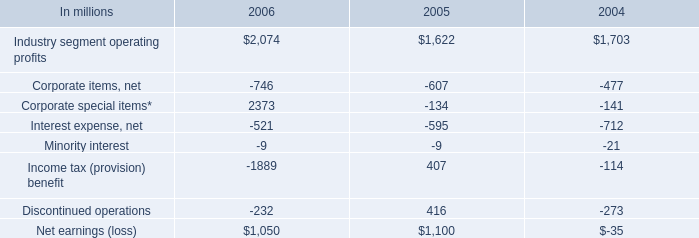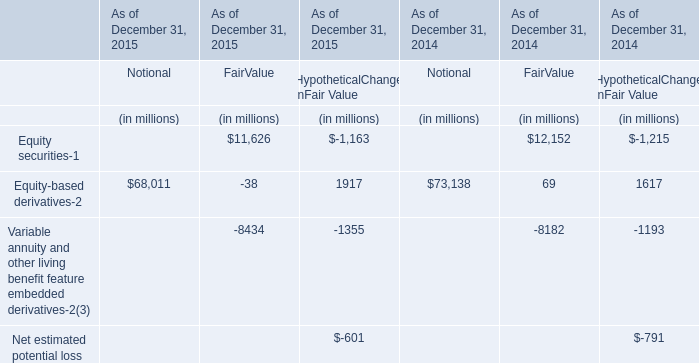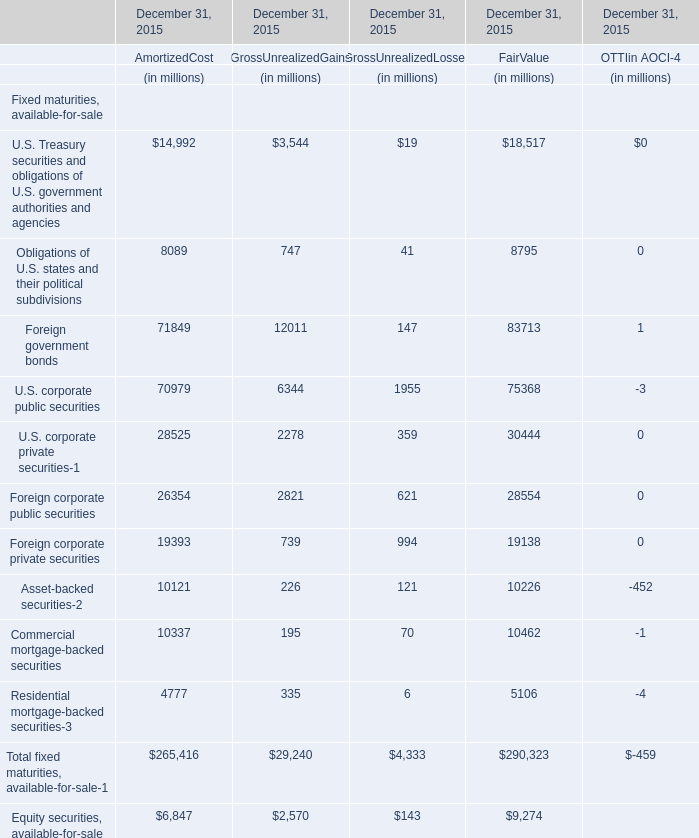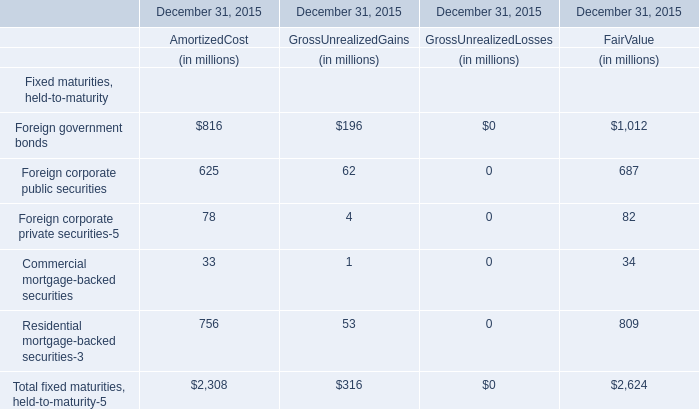Which section is Foreign corporate public securities for amortized cost the highest? 
Answer: Amortized Cost (625). 